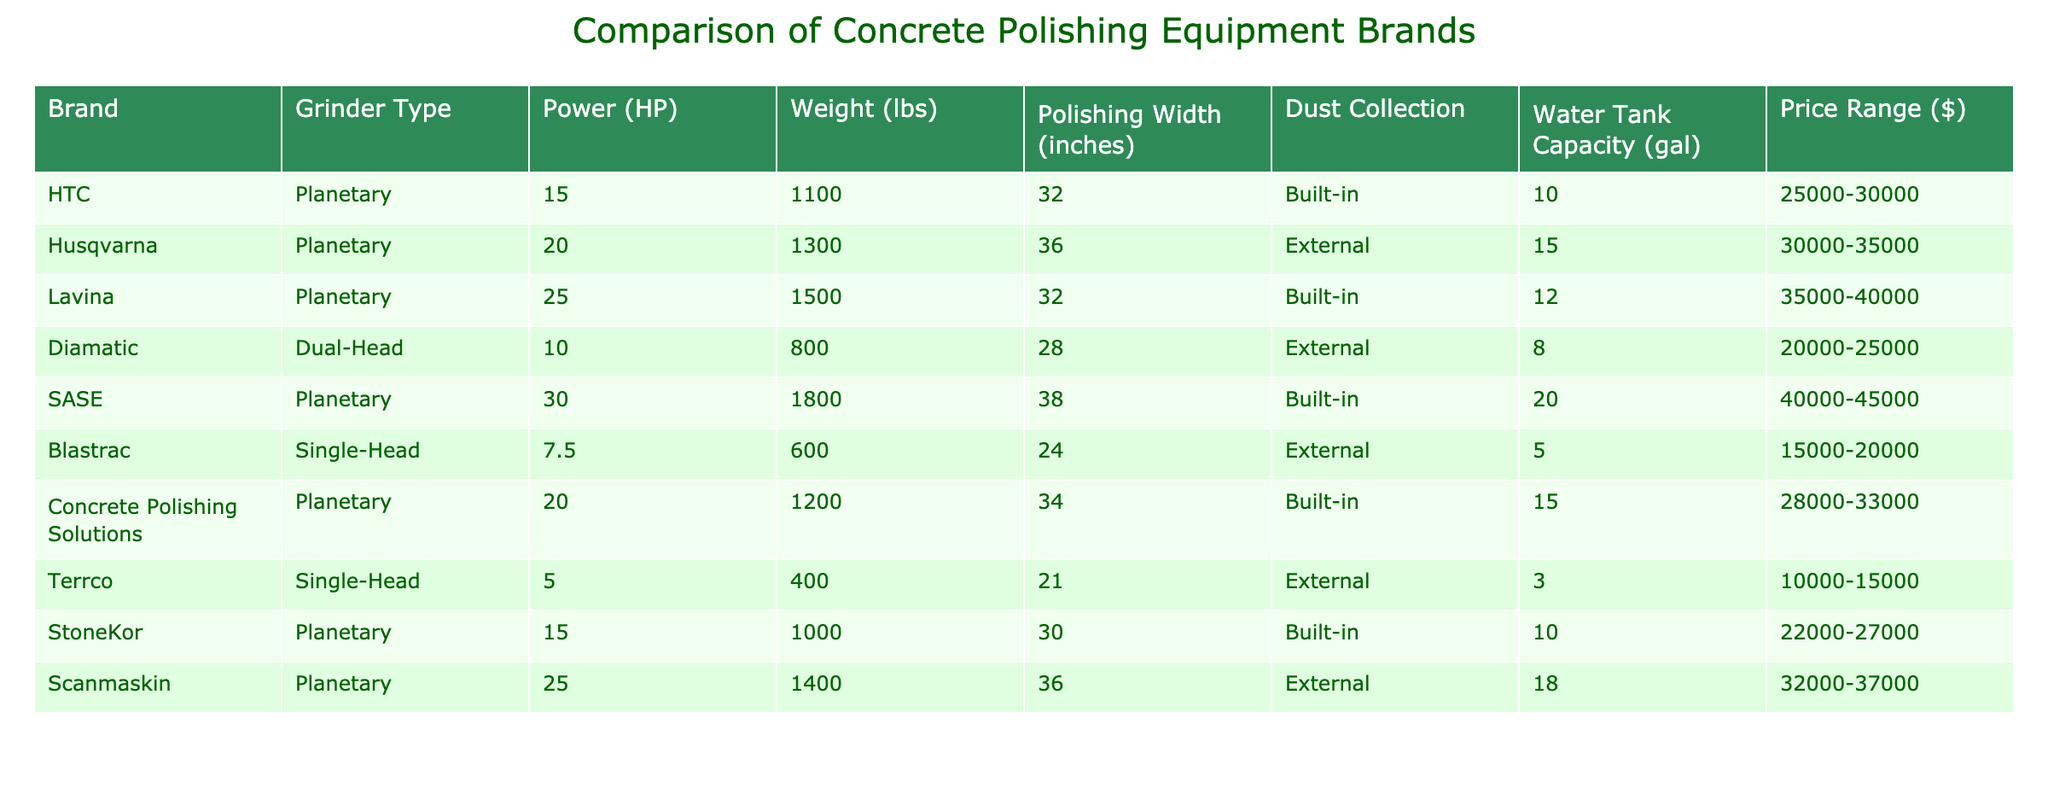What is the weight of the SASE grinder? The table indicates that the weight of the SASE grinder is 1800 lbs. This is a retrieval question that can be answered directly by locating the row for the SASE grinder in the table.
Answer: 1800 lbs Which brand offers the widest polishing width? From the table, the SASE brand offers a polishing width of 38 inches, which is greater than any other brand listed. This requires comparing all the polishing width values from the table to identify the maximum.
Answer: 38 inches Is there a grinder with a built-in dust collection system and an external water tank? The table shows that all grinders with a built-in dust collection system have a built-in water tank as well. Therefore, no grinder has an external water tank along with a built-in dust collection system. This conclusion is derived from analyzing both the dust collection and water tank capacity columns simultaneously.
Answer: No What is the average power of all the grinders listed? To find the average power, we sum the horsepower values: 15 + 20 + 25 + 10 + 30 + 7.5 + 20 + 5 + 15 + 25 = 177.5 HP. There are 10 grinders, so we divide the total power by 10. Thus, 177.5 / 10 = 17.75 HP. This question involves summing values and dividing to find the average.
Answer: 17.75 HP Does the Lavina brand have the highest price range? The Lavina brand is priced in the range of 35000 to 40000 dollars, which is lower than the SASE brand priced at 40000 to 45000 dollars. This requires comparing the price ranges of each brand to determine which is the highest.
Answer: No Which brands have a weight greater than 1200 lbs? The brands with a weight greater than 1200 lbs are Husqvarna (1300 lbs), Lavina (1500 lbs), SASE (1800 lbs), and Scanmaskin (1400 lbs). This is determined by filtering the weight column for values above 1200 lbs.
Answer: Husqvarna, Lavina, SASE, Scanmaskin What is the total water tank capacity of all the grinders with external dust collection? The grinders with external dust collection are Husqvarna, Diamatic, Blastrac, and Scanmaskin with water tank capacities of 15, 8, 5, and 18 gallons respectively. We sum these values: 15 + 8 + 5 + 18 = 46 gallons. This requires identifying the relevant rows and adding the water tank capacities.
Answer: 46 gallons Which brand has the lowest price range? The Blastrac brand has the lowest price range of 15000 to 20000 dollars when comparing the price ranges of all the brands in the table. This involves analyzing the price range of each brand to find the minimum.
Answer: 15000-20000 dollars 